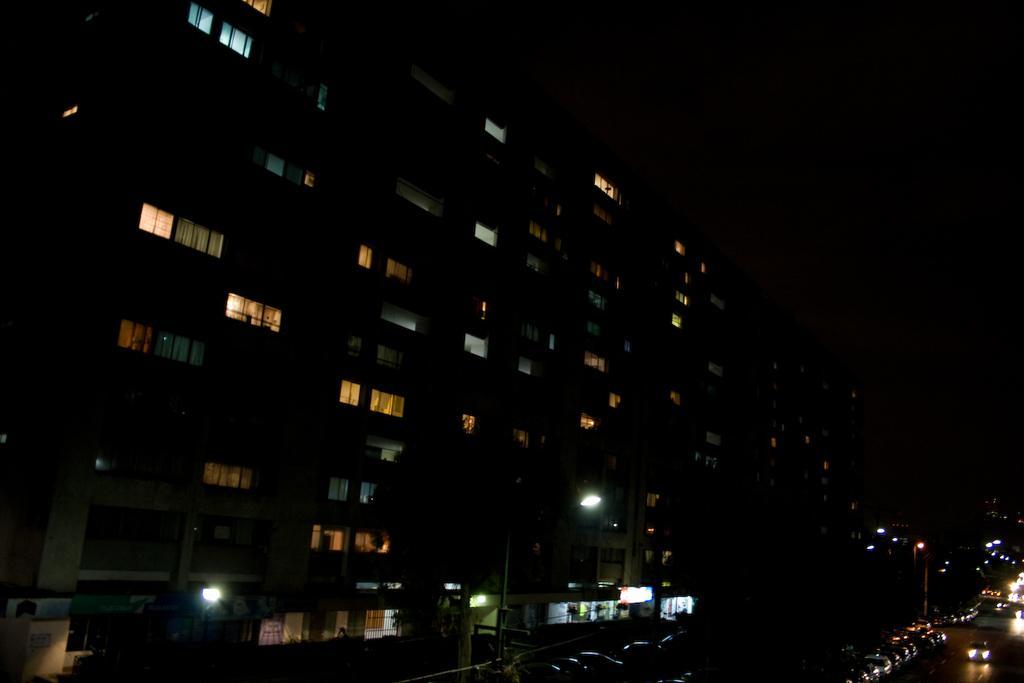Describe this image in one or two sentences. In the image we can see the building and the windows of the building. There are even vehicles on the road. Here we can see light poles and the dark sky. 